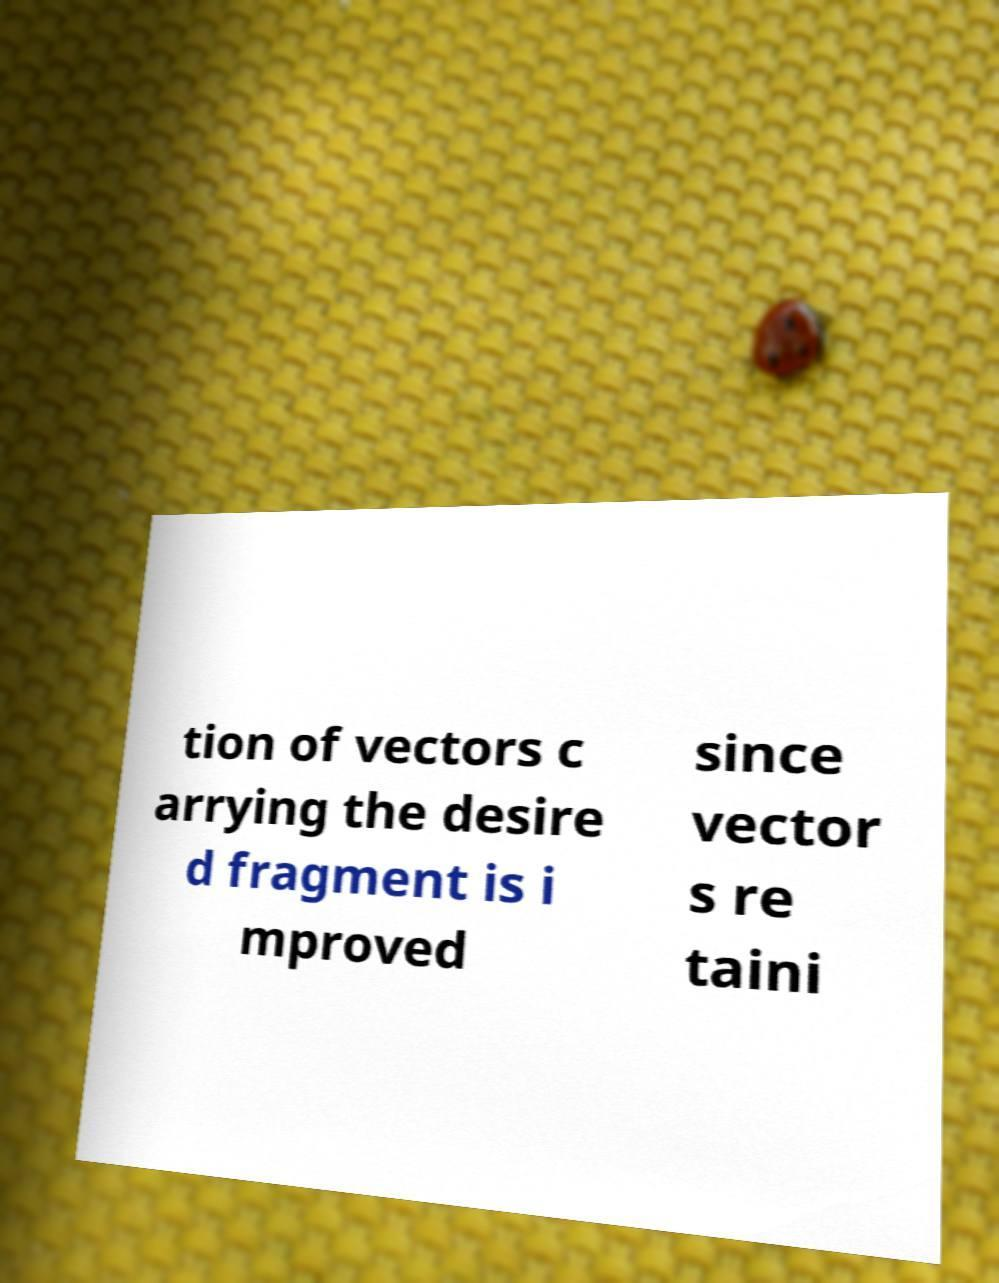Could you assist in decoding the text presented in this image and type it out clearly? tion of vectors c arrying the desire d fragment is i mproved since vector s re taini 